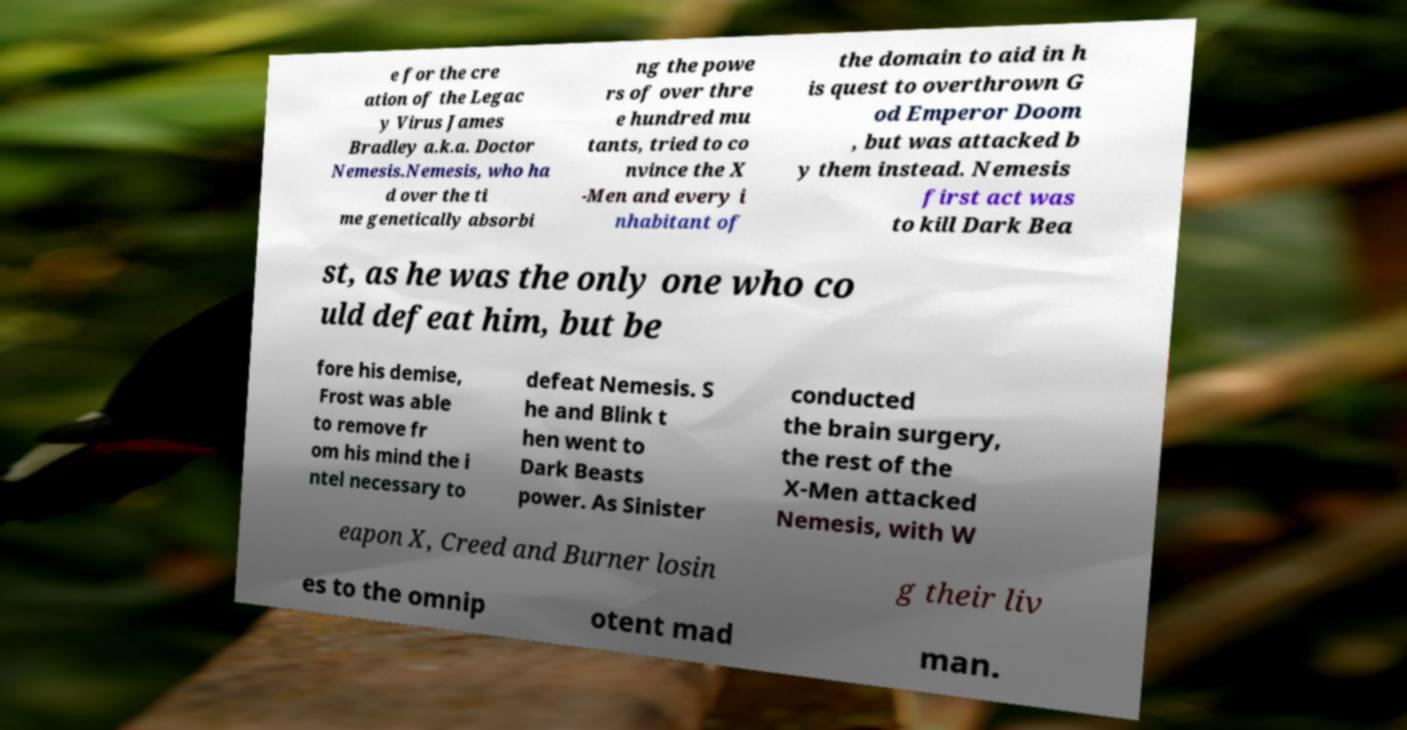I need the written content from this picture converted into text. Can you do that? e for the cre ation of the Legac y Virus James Bradley a.k.a. Doctor Nemesis.Nemesis, who ha d over the ti me genetically absorbi ng the powe rs of over thre e hundred mu tants, tried to co nvince the X -Men and every i nhabitant of the domain to aid in h is quest to overthrown G od Emperor Doom , but was attacked b y them instead. Nemesis first act was to kill Dark Bea st, as he was the only one who co uld defeat him, but be fore his demise, Frost was able to remove fr om his mind the i ntel necessary to defeat Nemesis. S he and Blink t hen went to Dark Beasts power. As Sinister conducted the brain surgery, the rest of the X-Men attacked Nemesis, with W eapon X, Creed and Burner losin g their liv es to the omnip otent mad man. 